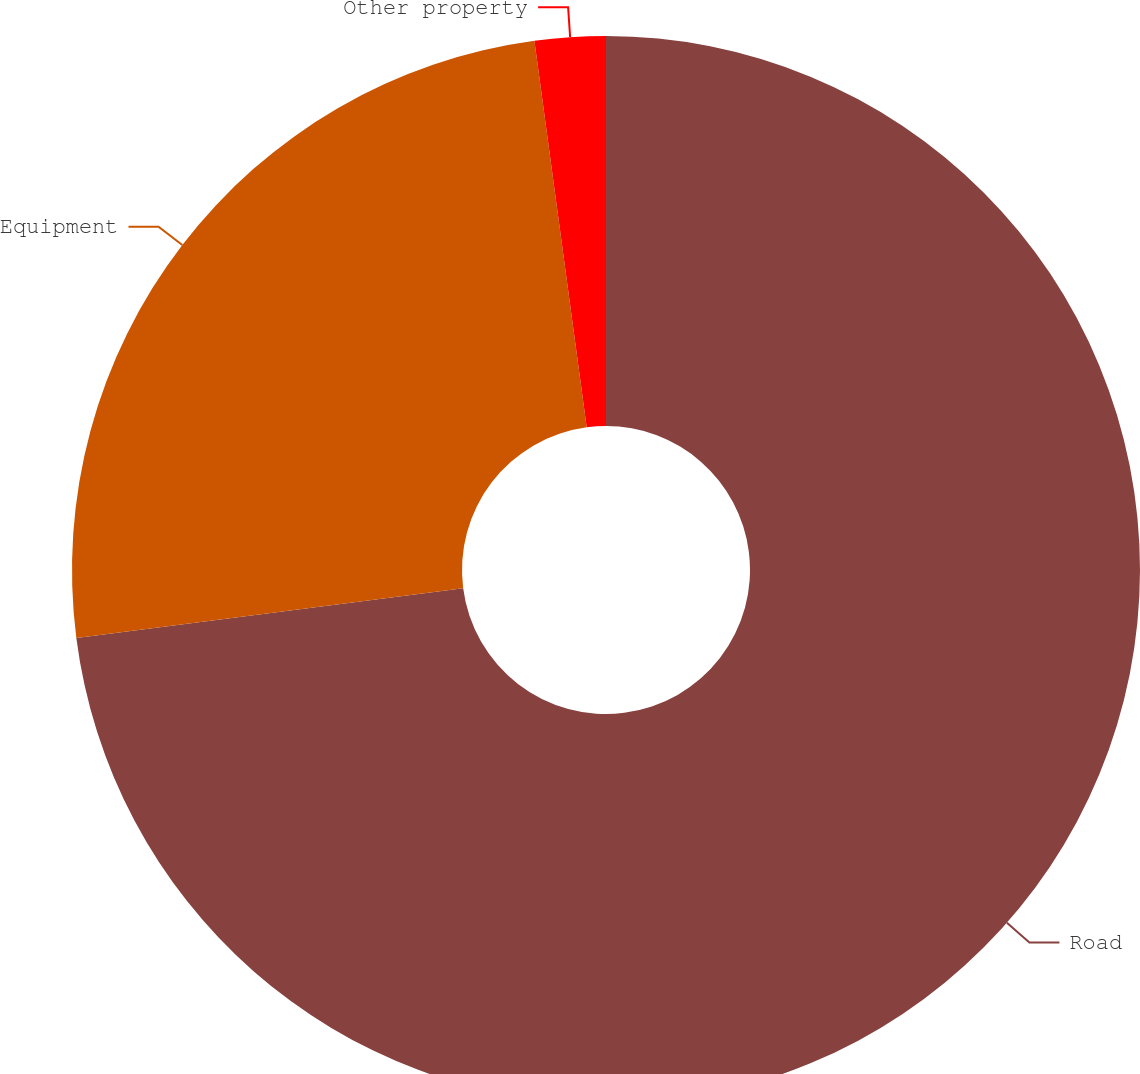<chart> <loc_0><loc_0><loc_500><loc_500><pie_chart><fcel>Road<fcel>Equipment<fcel>Other property<nl><fcel>72.97%<fcel>24.89%<fcel>2.14%<nl></chart> 